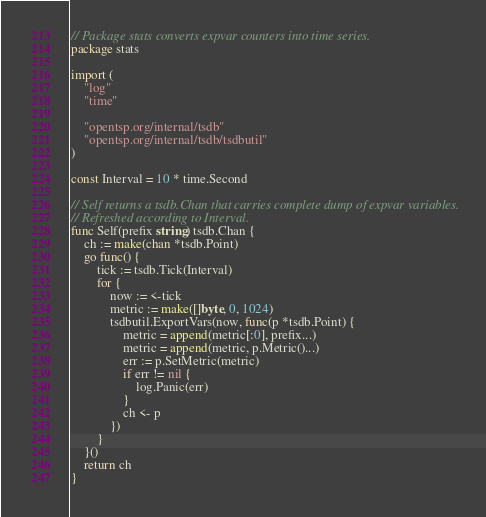<code> <loc_0><loc_0><loc_500><loc_500><_Go_>// Package stats converts expvar counters into time series.
package stats

import (
	"log"
	"time"

	"opentsp.org/internal/tsdb"
	"opentsp.org/internal/tsdb/tsdbutil"
)

const Interval = 10 * time.Second

// Self returns a tsdb.Chan that carries complete dump of expvar variables.
// Refreshed according to Interval.
func Self(prefix string) tsdb.Chan {
	ch := make(chan *tsdb.Point)
	go func() {
		tick := tsdb.Tick(Interval)
		for {
			now := <-tick
			metric := make([]byte, 0, 1024)
			tsdbutil.ExportVars(now, func(p *tsdb.Point) {
				metric = append(metric[:0], prefix...)
				metric = append(metric, p.Metric()...)
				err := p.SetMetric(metric)
				if err != nil {
					log.Panic(err)
				}
				ch <- p
			})
		}
	}()
	return ch
}
</code> 